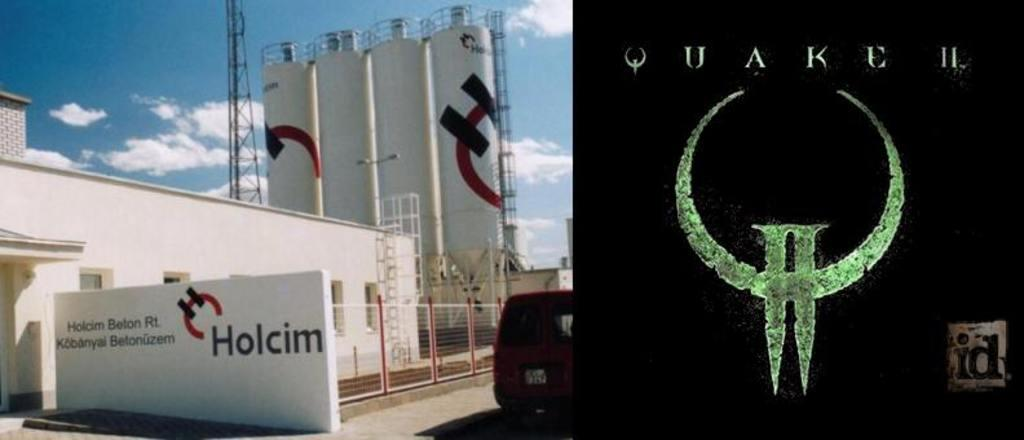What type of structure is visible in the image? There is a building in the image. What can be seen behind the building? There are four tall towers behind the building. What is parked in front of the building? There is a vehicle in front of the building. What can be seen in the distance in the image? The sky is visible in the background of the image. What type of plantation is visible in the image? There is no plantation present in the image. The image features a building, four tall towers, a vehicle, and the sky in the background. 